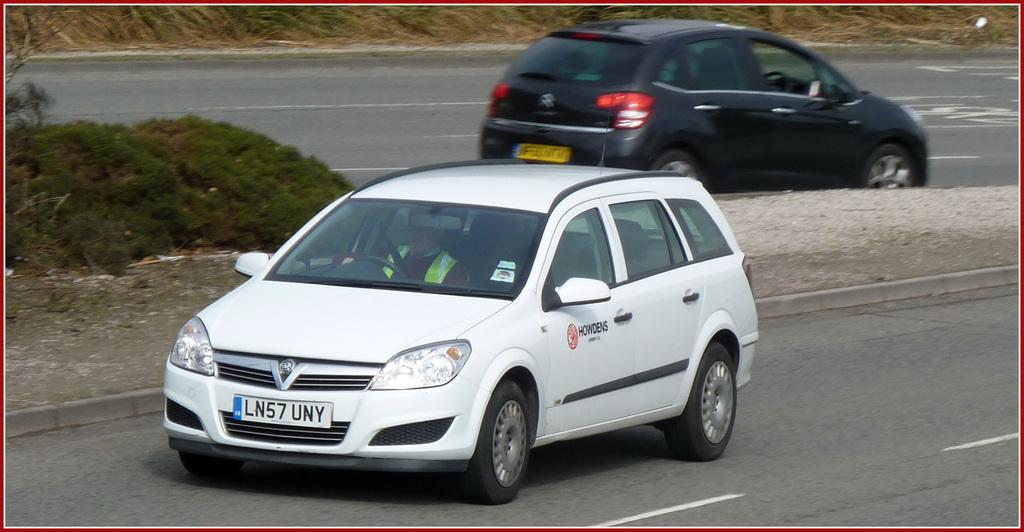<image>
Relay a brief, clear account of the picture shown. A white crossover with tag LN57 UNY on it. 